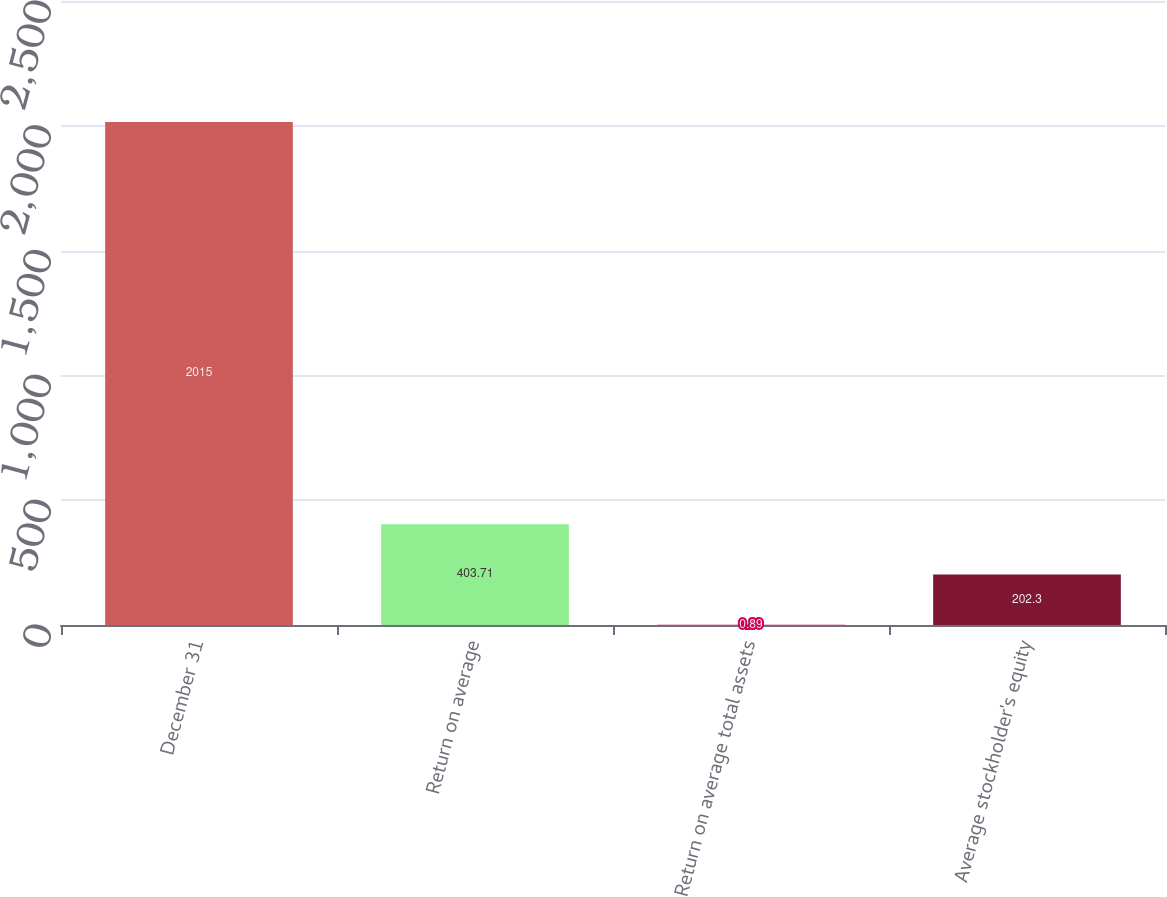Convert chart to OTSL. <chart><loc_0><loc_0><loc_500><loc_500><bar_chart><fcel>December 31<fcel>Return on average<fcel>Return on average total assets<fcel>Average stockholder's equity<nl><fcel>2015<fcel>403.71<fcel>0.89<fcel>202.3<nl></chart> 